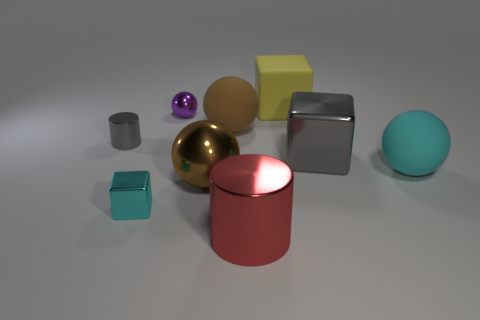Can you tell me the total number of objects present in the image? Yes, there are ten objects in the image. Each object has a distinct shape and color, which makes them easily countable. 